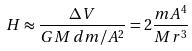Convert formula to latex. <formula><loc_0><loc_0><loc_500><loc_500>H \approx { \frac { \Delta V } { G M \, d m / A ^ { 2 } } } = 2 { \frac { m A ^ { 4 } } { M r ^ { 3 } } }</formula> 